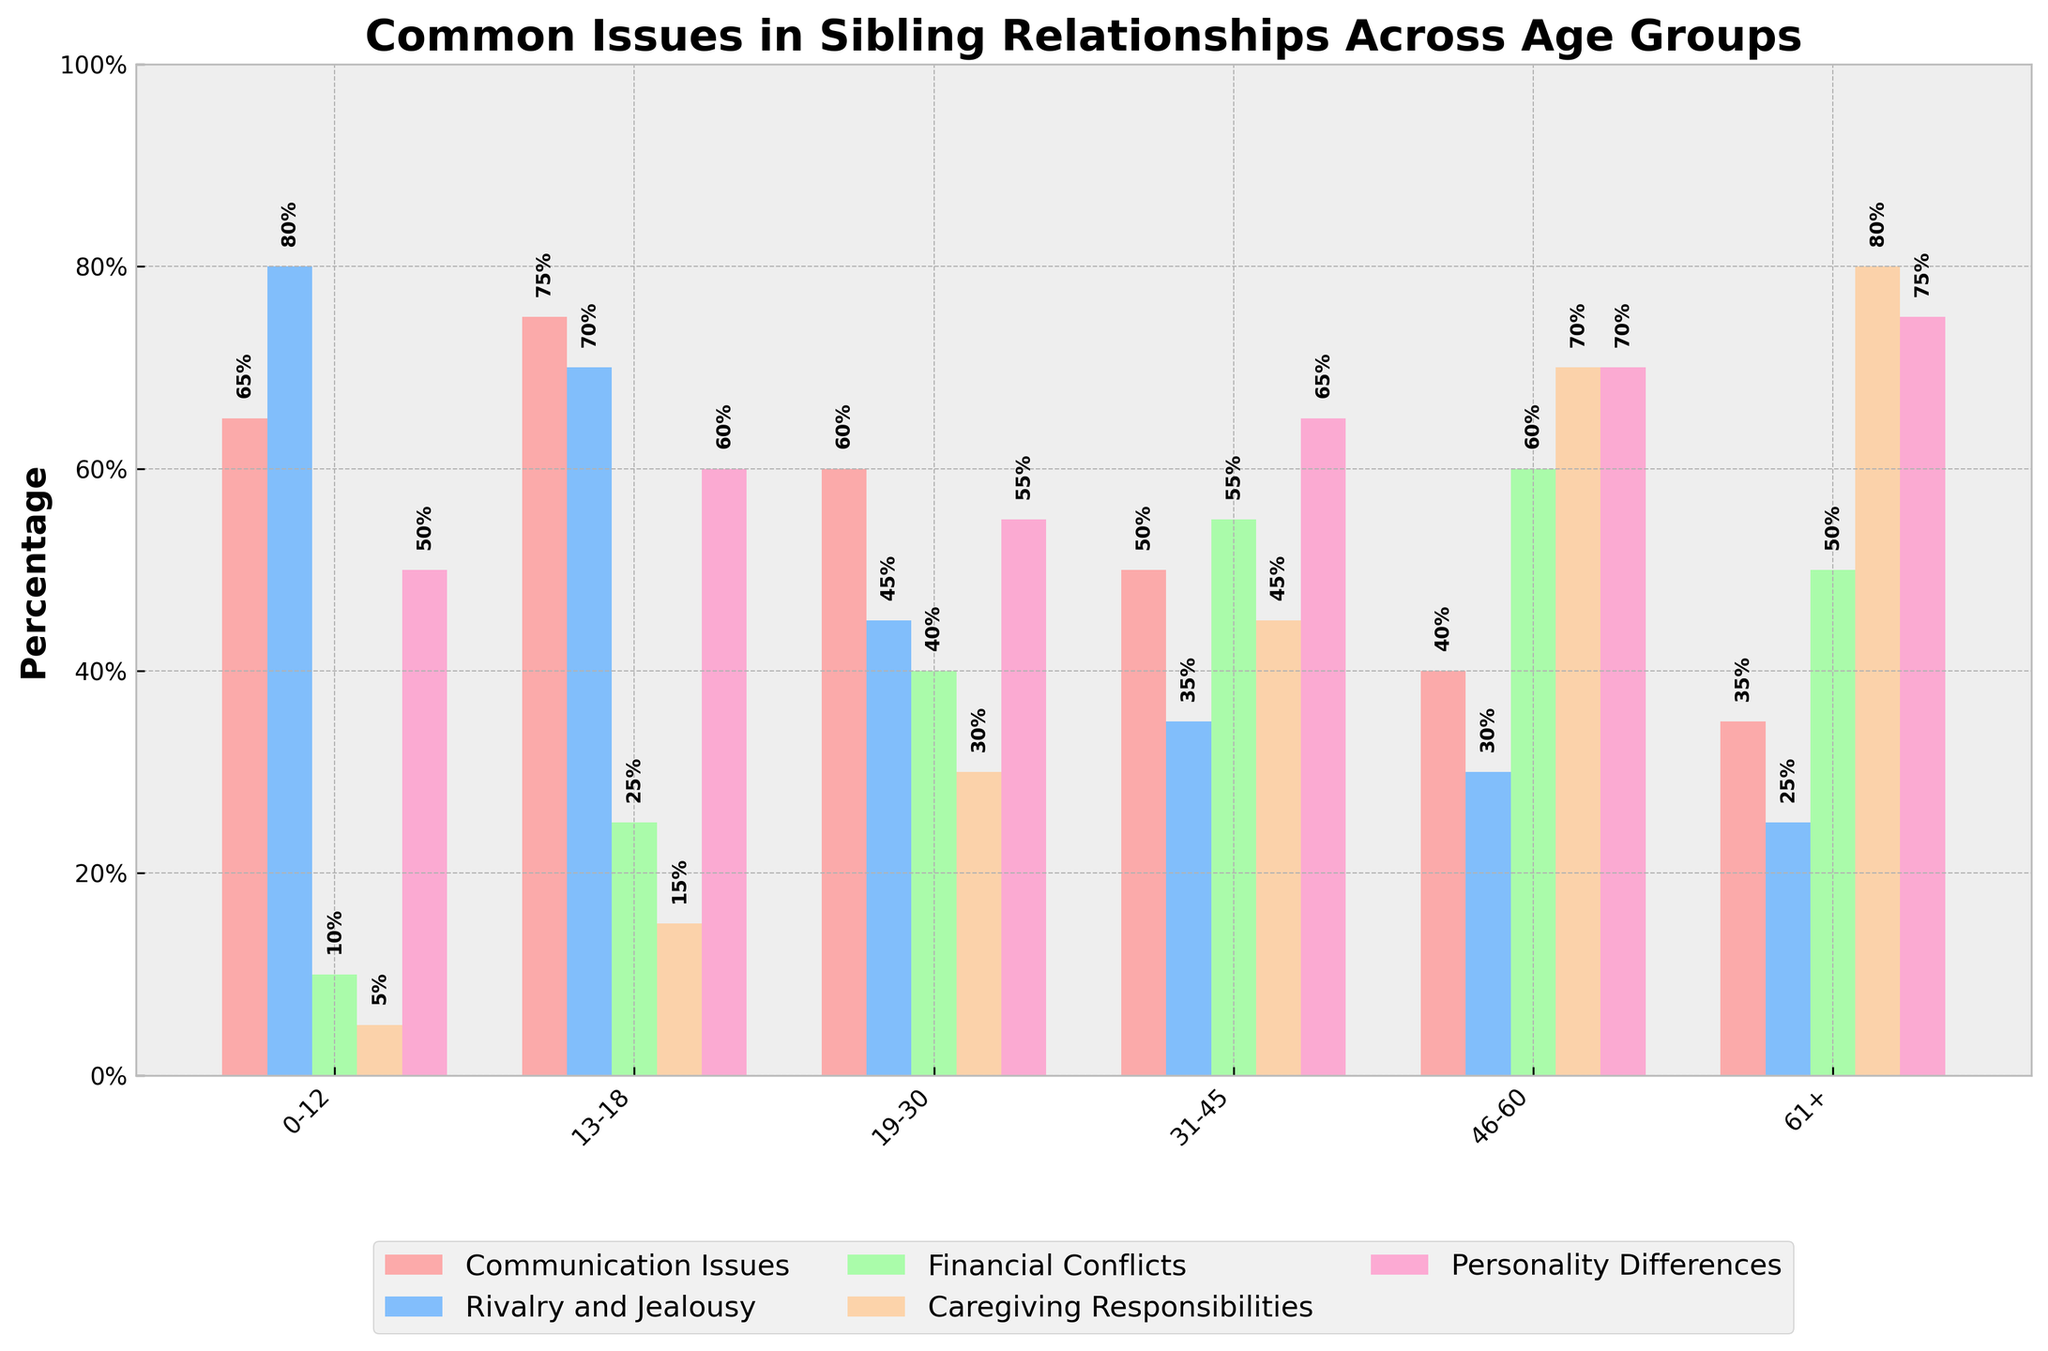Which age group has the highest percentage of rivalry and jealousy issues? The bar representing rivalry and jealousy for the age group 0-12 is the tallest.
Answer: 0-12 What is the difference in percentage points between financial conflicts in the 31-45 age group and the 61+ age group? The percentage for financial conflicts in the 31-45 age group is 55%, and for the 61+ age group, it is 50%. The difference is 55% - 50%.
Answer: 5% Which three age groups have the most significant communication issues percentages? The percentages for communication issues are highest in the 13-18, 0-12, and 19-30 age groups.
Answer: 13-18, 0-12, 19-30 In which age group does caregiving responsibilities peak? The tallest bar for caregiving responsibilities is in the 61+ age group.
Answer: 61+ How do the percentages of personality differences change from the 0-12 to the 61+ age group? Personality differences start at 50% for the 0-12 age group and increase to 75% for the 61+ age group. The change is 75% - 50%.
Answer: 25% increase Which issue has the lowest percentage in the 46-60 age group, and what is it? The smallest bar for the 46-60 age group is for rivalry and jealousy.
Answer: Rivalry and Jealousy, 30% What is the average percentage of financial conflicts across all age groups? Add the percentages: 10 + 25 + 40 + 55 + 60 + 50 = 240. The average is then 240 / 6.
Answer: 40% Compare the percentage points of personality differences between the 19-30 and 31-45 age groups. Which is higher by how much? The percentage for 19-30 is 55%, and for 31-45, it is 65%. The difference is 65% - 55%.
Answer: 31-45 by 10% What is the sum percentage of caregiving responsibilities for the 0-12 and 13-18 age groups? Add the percentages: 5% + 15% = 20%.
Answer: 20% Does financial conflicts or communication issues have higher percentages in the 46-60 age group? Compare the bars for financial conflicts (60%) and communication issues (40%).
Answer: Financial Conflicts, 60% 